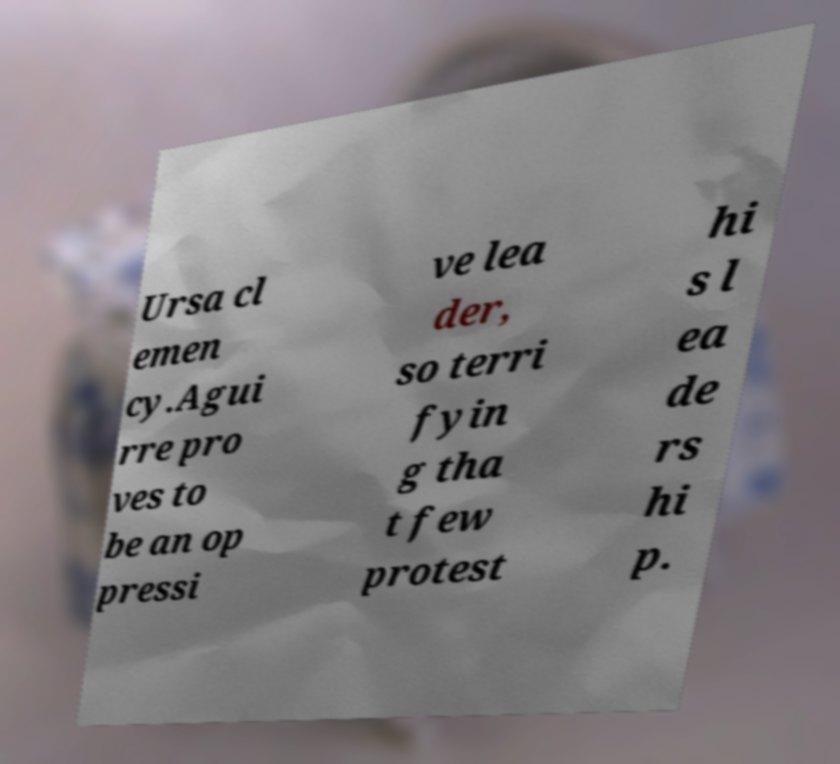Could you assist in decoding the text presented in this image and type it out clearly? Ursa cl emen cy.Agui rre pro ves to be an op pressi ve lea der, so terri fyin g tha t few protest hi s l ea de rs hi p. 